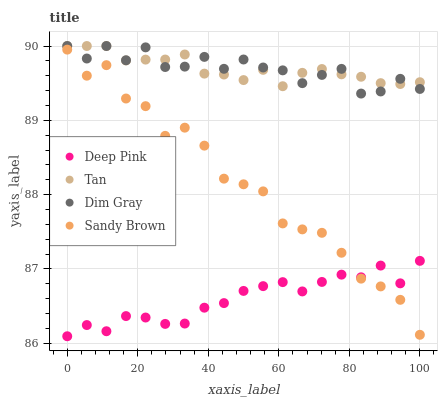Does Deep Pink have the minimum area under the curve?
Answer yes or no. Yes. Does Dim Gray have the maximum area under the curve?
Answer yes or no. Yes. Does Sandy Brown have the minimum area under the curve?
Answer yes or no. No. Does Sandy Brown have the maximum area under the curve?
Answer yes or no. No. Is Tan the smoothest?
Answer yes or no. Yes. Is Sandy Brown the roughest?
Answer yes or no. Yes. Is Deep Pink the smoothest?
Answer yes or no. No. Is Deep Pink the roughest?
Answer yes or no. No. Does Deep Pink have the lowest value?
Answer yes or no. Yes. Does Sandy Brown have the lowest value?
Answer yes or no. No. Does Dim Gray have the highest value?
Answer yes or no. Yes. Does Sandy Brown have the highest value?
Answer yes or no. No. Is Sandy Brown less than Tan?
Answer yes or no. Yes. Is Tan greater than Sandy Brown?
Answer yes or no. Yes. Does Tan intersect Dim Gray?
Answer yes or no. Yes. Is Tan less than Dim Gray?
Answer yes or no. No. Is Tan greater than Dim Gray?
Answer yes or no. No. Does Sandy Brown intersect Tan?
Answer yes or no. No. 